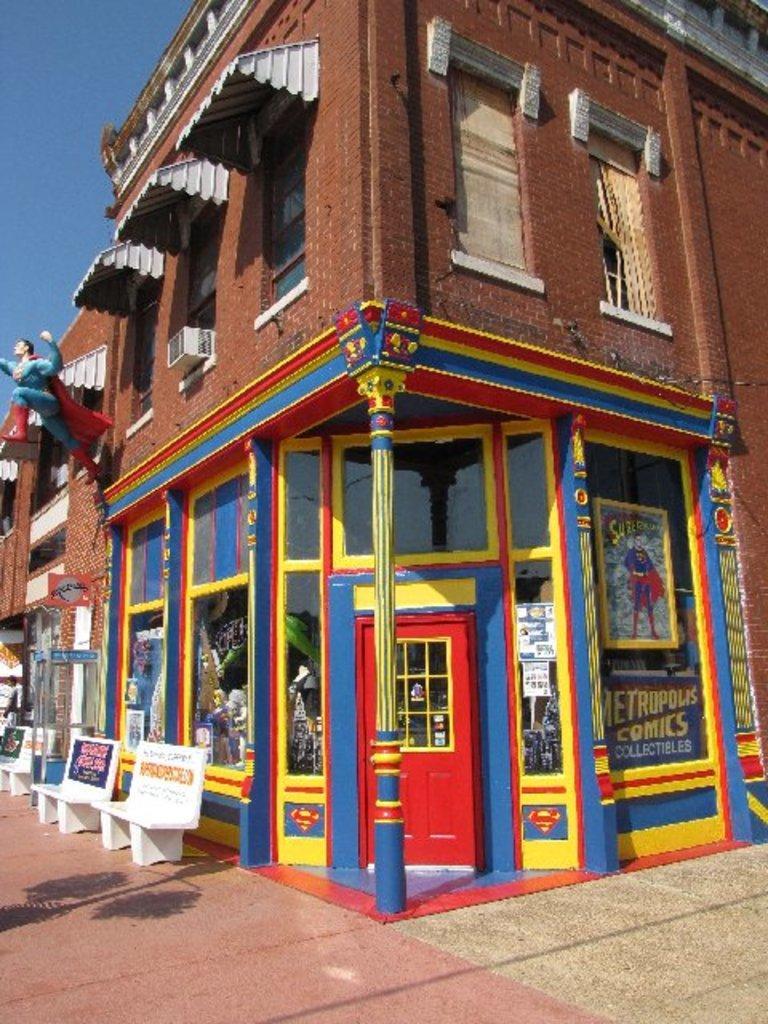How would you summarize this image in a sentence or two? In this image in the center there is building, and in front of the building there is a statue on the left side, and there are benches which are empty. On right side on the wall of the building there is some text written on it and there is a door which is red in colour. 